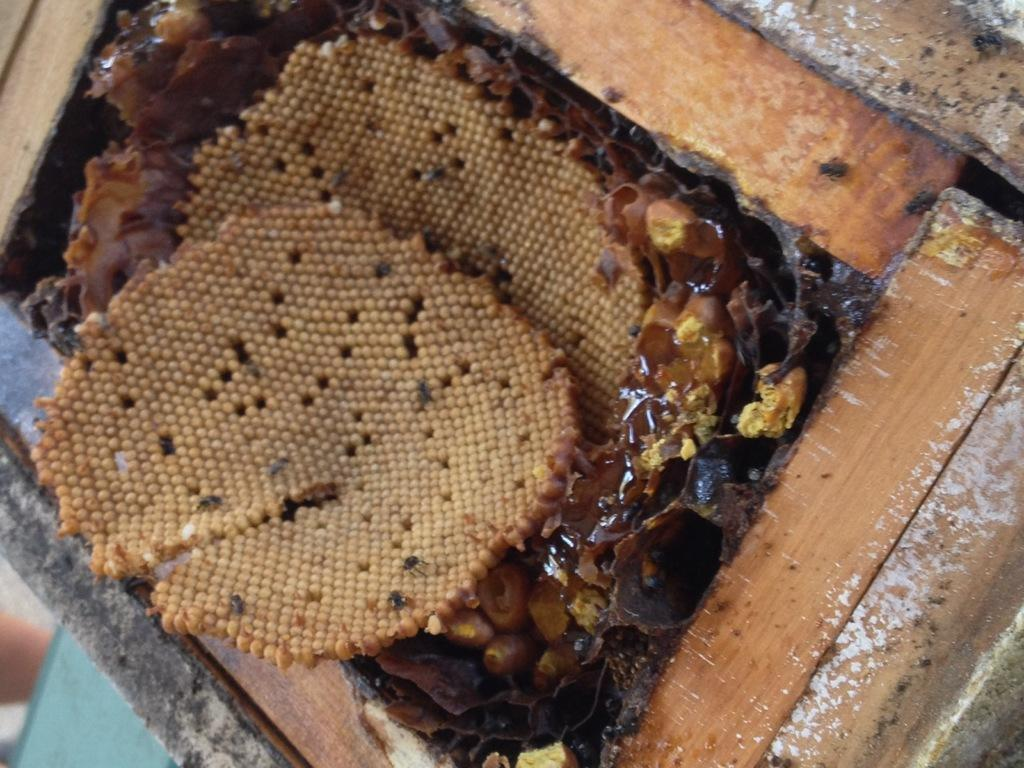What type of structures are present in the image? There are honey bee hives in the image. What other objects can be seen in the image? There are wooden sticks visible in the image. What time of day is it in the image? The time of day is not mentioned or depicted in the image. What type of test is being conducted in the image? There is no test being conducted in the image; it features honey bee hives and wooden sticks. How many letters are visible in the image? There is no reference to letters in the image; it only features honey bee hives and wooden sticks. 